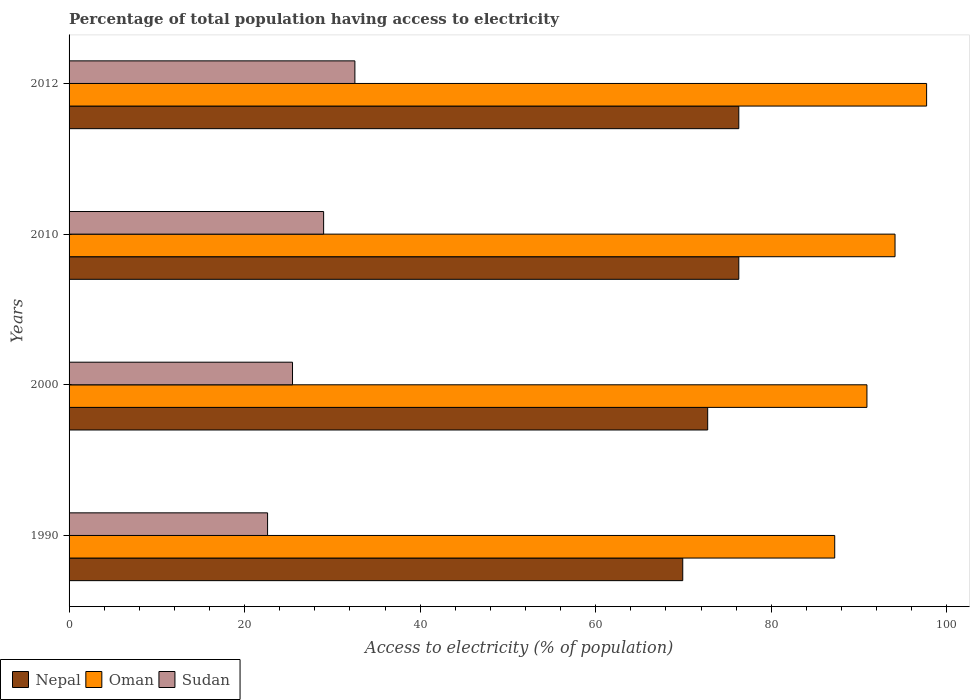How many different coloured bars are there?
Offer a terse response. 3. Are the number of bars per tick equal to the number of legend labels?
Keep it short and to the point. Yes. How many bars are there on the 3rd tick from the top?
Provide a succinct answer. 3. What is the label of the 2nd group of bars from the top?
Your answer should be compact. 2010. In how many cases, is the number of bars for a given year not equal to the number of legend labels?
Your answer should be very brief. 0. What is the percentage of population that have access to electricity in Nepal in 2010?
Provide a succinct answer. 76.3. Across all years, what is the maximum percentage of population that have access to electricity in Oman?
Offer a very short reply. 97.7. Across all years, what is the minimum percentage of population that have access to electricity in Oman?
Your answer should be very brief. 87.23. In which year was the percentage of population that have access to electricity in Oman maximum?
Your answer should be very brief. 2012. What is the total percentage of population that have access to electricity in Oman in the graph?
Offer a very short reply. 369.92. What is the difference between the percentage of population that have access to electricity in Sudan in 2010 and that in 2012?
Your answer should be very brief. -3.56. What is the difference between the percentage of population that have access to electricity in Nepal in 2000 and the percentage of population that have access to electricity in Sudan in 2012?
Your answer should be compact. 40.19. What is the average percentage of population that have access to electricity in Nepal per year?
Your response must be concise. 73.82. In the year 2012, what is the difference between the percentage of population that have access to electricity in Sudan and percentage of population that have access to electricity in Nepal?
Make the answer very short. -43.74. What is the ratio of the percentage of population that have access to electricity in Sudan in 1990 to that in 2010?
Your response must be concise. 0.78. What is the difference between the highest and the lowest percentage of population that have access to electricity in Oman?
Ensure brevity in your answer.  10.47. In how many years, is the percentage of population that have access to electricity in Nepal greater than the average percentage of population that have access to electricity in Nepal taken over all years?
Your answer should be compact. 2. Is the sum of the percentage of population that have access to electricity in Oman in 2000 and 2012 greater than the maximum percentage of population that have access to electricity in Sudan across all years?
Make the answer very short. Yes. What does the 2nd bar from the top in 2010 represents?
Give a very brief answer. Oman. What does the 1st bar from the bottom in 2012 represents?
Your answer should be very brief. Nepal. How many years are there in the graph?
Provide a short and direct response. 4. Are the values on the major ticks of X-axis written in scientific E-notation?
Offer a terse response. No. What is the title of the graph?
Offer a terse response. Percentage of total population having access to electricity. What is the label or title of the X-axis?
Offer a very short reply. Access to electricity (% of population). What is the Access to electricity (% of population) in Nepal in 1990?
Provide a succinct answer. 69.92. What is the Access to electricity (% of population) of Oman in 1990?
Make the answer very short. 87.23. What is the Access to electricity (% of population) of Sudan in 1990?
Your answer should be very brief. 22.62. What is the Access to electricity (% of population) in Nepal in 2000?
Offer a terse response. 72.76. What is the Access to electricity (% of population) in Oman in 2000?
Make the answer very short. 90.9. What is the Access to electricity (% of population) of Sudan in 2000?
Offer a terse response. 25.46. What is the Access to electricity (% of population) of Nepal in 2010?
Your answer should be compact. 76.3. What is the Access to electricity (% of population) of Oman in 2010?
Ensure brevity in your answer.  94.1. What is the Access to electricity (% of population) in Nepal in 2012?
Provide a short and direct response. 76.3. What is the Access to electricity (% of population) of Oman in 2012?
Offer a very short reply. 97.7. What is the Access to electricity (% of population) of Sudan in 2012?
Give a very brief answer. 32.56. Across all years, what is the maximum Access to electricity (% of population) of Nepal?
Ensure brevity in your answer.  76.3. Across all years, what is the maximum Access to electricity (% of population) in Oman?
Give a very brief answer. 97.7. Across all years, what is the maximum Access to electricity (% of population) in Sudan?
Offer a terse response. 32.56. Across all years, what is the minimum Access to electricity (% of population) of Nepal?
Provide a succinct answer. 69.92. Across all years, what is the minimum Access to electricity (% of population) of Oman?
Your response must be concise. 87.23. Across all years, what is the minimum Access to electricity (% of population) of Sudan?
Your response must be concise. 22.62. What is the total Access to electricity (% of population) in Nepal in the graph?
Offer a terse response. 295.27. What is the total Access to electricity (% of population) in Oman in the graph?
Make the answer very short. 369.92. What is the total Access to electricity (% of population) in Sudan in the graph?
Your answer should be compact. 109.63. What is the difference between the Access to electricity (% of population) in Nepal in 1990 and that in 2000?
Your answer should be very brief. -2.84. What is the difference between the Access to electricity (% of population) of Oman in 1990 and that in 2000?
Your response must be concise. -3.67. What is the difference between the Access to electricity (% of population) in Sudan in 1990 and that in 2000?
Ensure brevity in your answer.  -2.84. What is the difference between the Access to electricity (% of population) of Nepal in 1990 and that in 2010?
Ensure brevity in your answer.  -6.38. What is the difference between the Access to electricity (% of population) in Oman in 1990 and that in 2010?
Your answer should be compact. -6.87. What is the difference between the Access to electricity (% of population) of Sudan in 1990 and that in 2010?
Provide a succinct answer. -6.38. What is the difference between the Access to electricity (% of population) of Nepal in 1990 and that in 2012?
Provide a succinct answer. -6.38. What is the difference between the Access to electricity (% of population) in Oman in 1990 and that in 2012?
Your answer should be compact. -10.47. What is the difference between the Access to electricity (% of population) of Sudan in 1990 and that in 2012?
Provide a succinct answer. -9.95. What is the difference between the Access to electricity (% of population) of Nepal in 2000 and that in 2010?
Offer a terse response. -3.54. What is the difference between the Access to electricity (% of population) of Oman in 2000 and that in 2010?
Give a very brief answer. -3.2. What is the difference between the Access to electricity (% of population) of Sudan in 2000 and that in 2010?
Offer a terse response. -3.54. What is the difference between the Access to electricity (% of population) in Nepal in 2000 and that in 2012?
Your answer should be very brief. -3.54. What is the difference between the Access to electricity (% of population) of Oman in 2000 and that in 2012?
Keep it short and to the point. -6.8. What is the difference between the Access to electricity (% of population) in Sudan in 2000 and that in 2012?
Keep it short and to the point. -7.11. What is the difference between the Access to electricity (% of population) of Oman in 2010 and that in 2012?
Give a very brief answer. -3.6. What is the difference between the Access to electricity (% of population) of Sudan in 2010 and that in 2012?
Ensure brevity in your answer.  -3.56. What is the difference between the Access to electricity (% of population) of Nepal in 1990 and the Access to electricity (% of population) of Oman in 2000?
Keep it short and to the point. -20.98. What is the difference between the Access to electricity (% of population) in Nepal in 1990 and the Access to electricity (% of population) in Sudan in 2000?
Give a very brief answer. 44.46. What is the difference between the Access to electricity (% of population) of Oman in 1990 and the Access to electricity (% of population) of Sudan in 2000?
Keep it short and to the point. 61.77. What is the difference between the Access to electricity (% of population) of Nepal in 1990 and the Access to electricity (% of population) of Oman in 2010?
Offer a very short reply. -24.18. What is the difference between the Access to electricity (% of population) in Nepal in 1990 and the Access to electricity (% of population) in Sudan in 2010?
Offer a terse response. 40.92. What is the difference between the Access to electricity (% of population) in Oman in 1990 and the Access to electricity (% of population) in Sudan in 2010?
Ensure brevity in your answer.  58.23. What is the difference between the Access to electricity (% of population) in Nepal in 1990 and the Access to electricity (% of population) in Oman in 2012?
Make the answer very short. -27.78. What is the difference between the Access to electricity (% of population) of Nepal in 1990 and the Access to electricity (% of population) of Sudan in 2012?
Offer a very short reply. 37.35. What is the difference between the Access to electricity (% of population) of Oman in 1990 and the Access to electricity (% of population) of Sudan in 2012?
Provide a short and direct response. 54.67. What is the difference between the Access to electricity (% of population) of Nepal in 2000 and the Access to electricity (% of population) of Oman in 2010?
Give a very brief answer. -21.34. What is the difference between the Access to electricity (% of population) of Nepal in 2000 and the Access to electricity (% of population) of Sudan in 2010?
Keep it short and to the point. 43.76. What is the difference between the Access to electricity (% of population) in Oman in 2000 and the Access to electricity (% of population) in Sudan in 2010?
Keep it short and to the point. 61.9. What is the difference between the Access to electricity (% of population) of Nepal in 2000 and the Access to electricity (% of population) of Oman in 2012?
Ensure brevity in your answer.  -24.94. What is the difference between the Access to electricity (% of population) of Nepal in 2000 and the Access to electricity (% of population) of Sudan in 2012?
Your answer should be very brief. 40.19. What is the difference between the Access to electricity (% of population) of Oman in 2000 and the Access to electricity (% of population) of Sudan in 2012?
Keep it short and to the point. 58.34. What is the difference between the Access to electricity (% of population) of Nepal in 2010 and the Access to electricity (% of population) of Oman in 2012?
Your response must be concise. -21.4. What is the difference between the Access to electricity (% of population) of Nepal in 2010 and the Access to electricity (% of population) of Sudan in 2012?
Your answer should be compact. 43.74. What is the difference between the Access to electricity (% of population) in Oman in 2010 and the Access to electricity (% of population) in Sudan in 2012?
Give a very brief answer. 61.54. What is the average Access to electricity (% of population) in Nepal per year?
Ensure brevity in your answer.  73.82. What is the average Access to electricity (% of population) of Oman per year?
Offer a terse response. 92.48. What is the average Access to electricity (% of population) in Sudan per year?
Give a very brief answer. 27.41. In the year 1990, what is the difference between the Access to electricity (% of population) of Nepal and Access to electricity (% of population) of Oman?
Your response must be concise. -17.31. In the year 1990, what is the difference between the Access to electricity (% of population) in Nepal and Access to electricity (% of population) in Sudan?
Your response must be concise. 47.3. In the year 1990, what is the difference between the Access to electricity (% of population) in Oman and Access to electricity (% of population) in Sudan?
Your response must be concise. 64.61. In the year 2000, what is the difference between the Access to electricity (% of population) of Nepal and Access to electricity (% of population) of Oman?
Offer a very short reply. -18.14. In the year 2000, what is the difference between the Access to electricity (% of population) in Nepal and Access to electricity (% of population) in Sudan?
Give a very brief answer. 47.3. In the year 2000, what is the difference between the Access to electricity (% of population) of Oman and Access to electricity (% of population) of Sudan?
Make the answer very short. 65.44. In the year 2010, what is the difference between the Access to electricity (% of population) of Nepal and Access to electricity (% of population) of Oman?
Keep it short and to the point. -17.8. In the year 2010, what is the difference between the Access to electricity (% of population) in Nepal and Access to electricity (% of population) in Sudan?
Make the answer very short. 47.3. In the year 2010, what is the difference between the Access to electricity (% of population) of Oman and Access to electricity (% of population) of Sudan?
Provide a short and direct response. 65.1. In the year 2012, what is the difference between the Access to electricity (% of population) of Nepal and Access to electricity (% of population) of Oman?
Your answer should be compact. -21.4. In the year 2012, what is the difference between the Access to electricity (% of population) in Nepal and Access to electricity (% of population) in Sudan?
Keep it short and to the point. 43.74. In the year 2012, what is the difference between the Access to electricity (% of population) of Oman and Access to electricity (% of population) of Sudan?
Offer a very short reply. 65.14. What is the ratio of the Access to electricity (% of population) of Oman in 1990 to that in 2000?
Ensure brevity in your answer.  0.96. What is the ratio of the Access to electricity (% of population) of Sudan in 1990 to that in 2000?
Provide a short and direct response. 0.89. What is the ratio of the Access to electricity (% of population) of Nepal in 1990 to that in 2010?
Offer a terse response. 0.92. What is the ratio of the Access to electricity (% of population) in Oman in 1990 to that in 2010?
Your answer should be very brief. 0.93. What is the ratio of the Access to electricity (% of population) in Sudan in 1990 to that in 2010?
Make the answer very short. 0.78. What is the ratio of the Access to electricity (% of population) of Nepal in 1990 to that in 2012?
Make the answer very short. 0.92. What is the ratio of the Access to electricity (% of population) of Oman in 1990 to that in 2012?
Your answer should be very brief. 0.89. What is the ratio of the Access to electricity (% of population) in Sudan in 1990 to that in 2012?
Your answer should be very brief. 0.69. What is the ratio of the Access to electricity (% of population) of Nepal in 2000 to that in 2010?
Provide a succinct answer. 0.95. What is the ratio of the Access to electricity (% of population) of Oman in 2000 to that in 2010?
Give a very brief answer. 0.97. What is the ratio of the Access to electricity (% of population) of Sudan in 2000 to that in 2010?
Keep it short and to the point. 0.88. What is the ratio of the Access to electricity (% of population) in Nepal in 2000 to that in 2012?
Keep it short and to the point. 0.95. What is the ratio of the Access to electricity (% of population) of Oman in 2000 to that in 2012?
Your response must be concise. 0.93. What is the ratio of the Access to electricity (% of population) in Sudan in 2000 to that in 2012?
Your response must be concise. 0.78. What is the ratio of the Access to electricity (% of population) in Nepal in 2010 to that in 2012?
Your answer should be very brief. 1. What is the ratio of the Access to electricity (% of population) of Oman in 2010 to that in 2012?
Make the answer very short. 0.96. What is the ratio of the Access to electricity (% of population) of Sudan in 2010 to that in 2012?
Your answer should be compact. 0.89. What is the difference between the highest and the second highest Access to electricity (% of population) of Oman?
Your answer should be very brief. 3.6. What is the difference between the highest and the second highest Access to electricity (% of population) in Sudan?
Your answer should be very brief. 3.56. What is the difference between the highest and the lowest Access to electricity (% of population) of Nepal?
Your answer should be very brief. 6.38. What is the difference between the highest and the lowest Access to electricity (% of population) of Oman?
Provide a succinct answer. 10.47. What is the difference between the highest and the lowest Access to electricity (% of population) of Sudan?
Give a very brief answer. 9.95. 